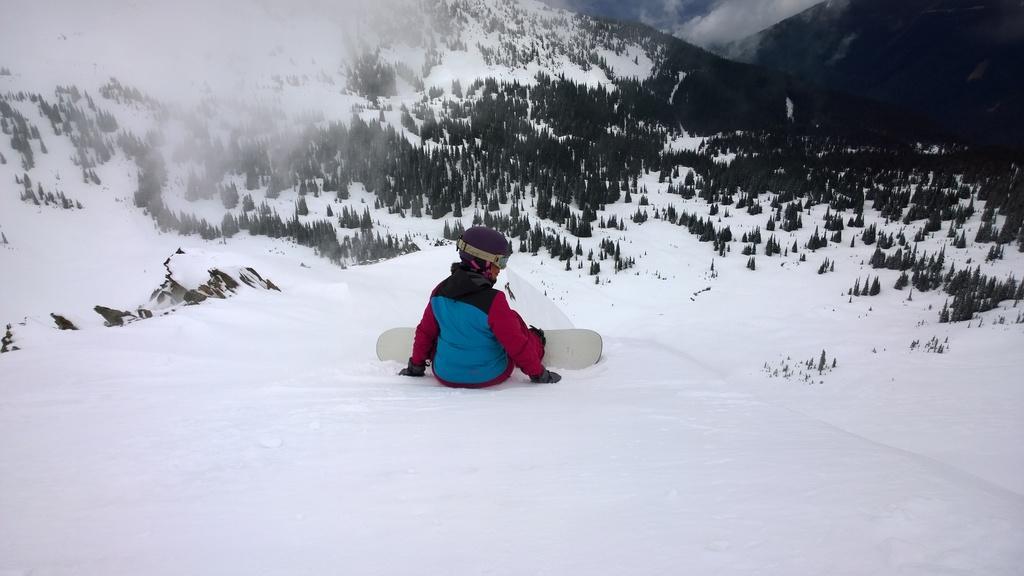Could you give a brief overview of what you see in this image? In this image, we can see a person and skateboard on the snow. There are some trees in the middle of the image. There is a hill at the top of the image. 